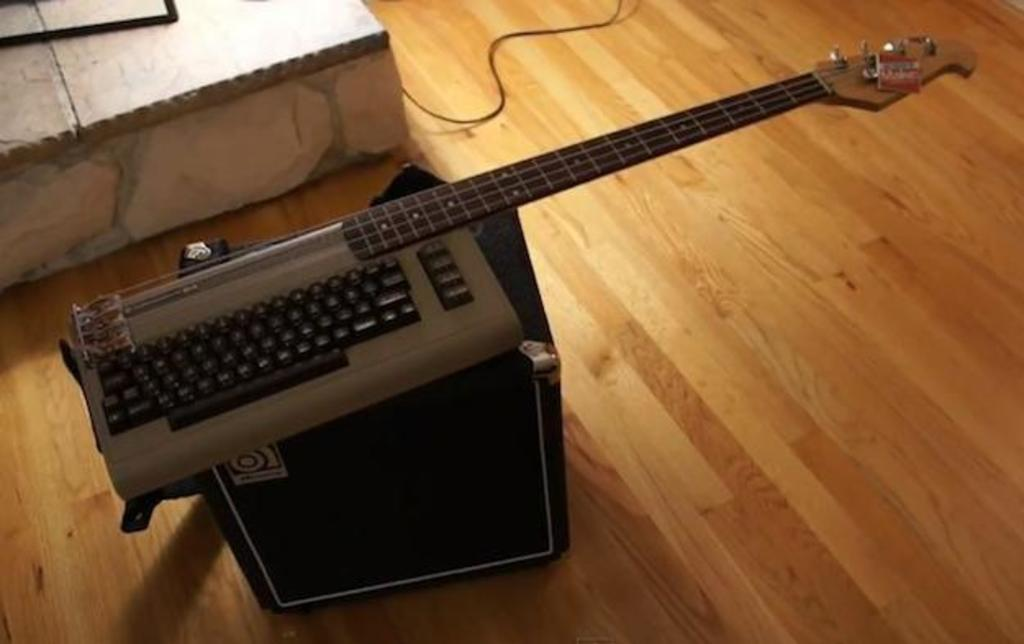What is the main object on the wooden floor in the image? There is a black box on the wooden floor. What is placed on top of the black box? There is a keyboard and a guitar on the black box. Can you describe any connecting elements in the image? There is a cable in the image. What other unspecified objects can be seen in the image? There are some unspecified objects in the image. What type of humor is being displayed by the visitor in the image? There is no visitor present in the image, so it is not possible to determine if any humor is being displayed. 